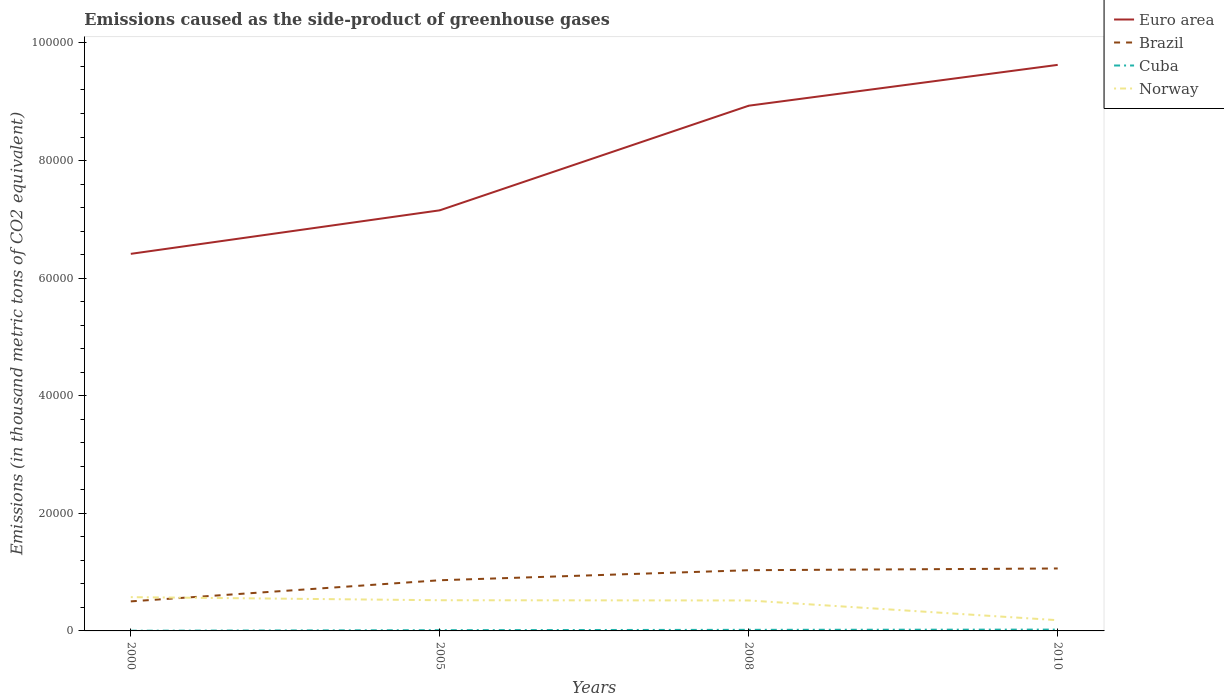Across all years, what is the maximum emissions caused as the side-product of greenhouse gases in Brazil?
Offer a terse response. 5025.2. What is the total emissions caused as the side-product of greenhouse gases in Brazil in the graph?
Offer a very short reply. -2003.5. What is the difference between the highest and the second highest emissions caused as the side-product of greenhouse gases in Norway?
Keep it short and to the point. 3919.8. What is the difference between the highest and the lowest emissions caused as the side-product of greenhouse gases in Euro area?
Keep it short and to the point. 2. How many years are there in the graph?
Your answer should be compact. 4. Are the values on the major ticks of Y-axis written in scientific E-notation?
Your response must be concise. No. Where does the legend appear in the graph?
Provide a short and direct response. Top right. What is the title of the graph?
Provide a short and direct response. Emissions caused as the side-product of greenhouse gases. What is the label or title of the X-axis?
Ensure brevity in your answer.  Years. What is the label or title of the Y-axis?
Give a very brief answer. Emissions (in thousand metric tons of CO2 equivalent). What is the Emissions (in thousand metric tons of CO2 equivalent) in Euro area in 2000?
Give a very brief answer. 6.41e+04. What is the Emissions (in thousand metric tons of CO2 equivalent) of Brazil in 2000?
Offer a terse response. 5025.2. What is the Emissions (in thousand metric tons of CO2 equivalent) of Cuba in 2000?
Your response must be concise. 34.2. What is the Emissions (in thousand metric tons of CO2 equivalent) in Norway in 2000?
Your answer should be very brief. 5742.8. What is the Emissions (in thousand metric tons of CO2 equivalent) in Euro area in 2005?
Keep it short and to the point. 7.15e+04. What is the Emissions (in thousand metric tons of CO2 equivalent) in Brazil in 2005?
Your response must be concise. 8617.5. What is the Emissions (in thousand metric tons of CO2 equivalent) in Cuba in 2005?
Offer a very short reply. 127.8. What is the Emissions (in thousand metric tons of CO2 equivalent) in Norway in 2005?
Your answer should be very brief. 5218.5. What is the Emissions (in thousand metric tons of CO2 equivalent) in Euro area in 2008?
Your answer should be compact. 8.93e+04. What is the Emissions (in thousand metric tons of CO2 equivalent) in Brazil in 2008?
Ensure brevity in your answer.  1.03e+04. What is the Emissions (in thousand metric tons of CO2 equivalent) of Cuba in 2008?
Provide a succinct answer. 185.9. What is the Emissions (in thousand metric tons of CO2 equivalent) in Norway in 2008?
Keep it short and to the point. 5179.9. What is the Emissions (in thousand metric tons of CO2 equivalent) of Euro area in 2010?
Ensure brevity in your answer.  9.63e+04. What is the Emissions (in thousand metric tons of CO2 equivalent) in Brazil in 2010?
Offer a very short reply. 1.06e+04. What is the Emissions (in thousand metric tons of CO2 equivalent) in Cuba in 2010?
Provide a succinct answer. 226. What is the Emissions (in thousand metric tons of CO2 equivalent) of Norway in 2010?
Keep it short and to the point. 1823. Across all years, what is the maximum Emissions (in thousand metric tons of CO2 equivalent) of Euro area?
Give a very brief answer. 9.63e+04. Across all years, what is the maximum Emissions (in thousand metric tons of CO2 equivalent) of Brazil?
Make the answer very short. 1.06e+04. Across all years, what is the maximum Emissions (in thousand metric tons of CO2 equivalent) of Cuba?
Make the answer very short. 226. Across all years, what is the maximum Emissions (in thousand metric tons of CO2 equivalent) in Norway?
Ensure brevity in your answer.  5742.8. Across all years, what is the minimum Emissions (in thousand metric tons of CO2 equivalent) of Euro area?
Ensure brevity in your answer.  6.41e+04. Across all years, what is the minimum Emissions (in thousand metric tons of CO2 equivalent) of Brazil?
Your answer should be very brief. 5025.2. Across all years, what is the minimum Emissions (in thousand metric tons of CO2 equivalent) in Cuba?
Give a very brief answer. 34.2. Across all years, what is the minimum Emissions (in thousand metric tons of CO2 equivalent) of Norway?
Offer a terse response. 1823. What is the total Emissions (in thousand metric tons of CO2 equivalent) of Euro area in the graph?
Offer a very short reply. 3.21e+05. What is the total Emissions (in thousand metric tons of CO2 equivalent) in Brazil in the graph?
Offer a very short reply. 3.46e+04. What is the total Emissions (in thousand metric tons of CO2 equivalent) in Cuba in the graph?
Make the answer very short. 573.9. What is the total Emissions (in thousand metric tons of CO2 equivalent) of Norway in the graph?
Make the answer very short. 1.80e+04. What is the difference between the Emissions (in thousand metric tons of CO2 equivalent) of Euro area in 2000 and that in 2005?
Make the answer very short. -7401.3. What is the difference between the Emissions (in thousand metric tons of CO2 equivalent) in Brazil in 2000 and that in 2005?
Offer a terse response. -3592.3. What is the difference between the Emissions (in thousand metric tons of CO2 equivalent) in Cuba in 2000 and that in 2005?
Provide a succinct answer. -93.6. What is the difference between the Emissions (in thousand metric tons of CO2 equivalent) in Norway in 2000 and that in 2005?
Your response must be concise. 524.3. What is the difference between the Emissions (in thousand metric tons of CO2 equivalent) in Euro area in 2000 and that in 2008?
Keep it short and to the point. -2.52e+04. What is the difference between the Emissions (in thousand metric tons of CO2 equivalent) in Brazil in 2000 and that in 2008?
Keep it short and to the point. -5301.4. What is the difference between the Emissions (in thousand metric tons of CO2 equivalent) of Cuba in 2000 and that in 2008?
Offer a terse response. -151.7. What is the difference between the Emissions (in thousand metric tons of CO2 equivalent) of Norway in 2000 and that in 2008?
Provide a short and direct response. 562.9. What is the difference between the Emissions (in thousand metric tons of CO2 equivalent) in Euro area in 2000 and that in 2010?
Ensure brevity in your answer.  -3.21e+04. What is the difference between the Emissions (in thousand metric tons of CO2 equivalent) in Brazil in 2000 and that in 2010?
Ensure brevity in your answer.  -5595.8. What is the difference between the Emissions (in thousand metric tons of CO2 equivalent) of Cuba in 2000 and that in 2010?
Keep it short and to the point. -191.8. What is the difference between the Emissions (in thousand metric tons of CO2 equivalent) of Norway in 2000 and that in 2010?
Offer a terse response. 3919.8. What is the difference between the Emissions (in thousand metric tons of CO2 equivalent) in Euro area in 2005 and that in 2008?
Your answer should be compact. -1.78e+04. What is the difference between the Emissions (in thousand metric tons of CO2 equivalent) in Brazil in 2005 and that in 2008?
Make the answer very short. -1709.1. What is the difference between the Emissions (in thousand metric tons of CO2 equivalent) in Cuba in 2005 and that in 2008?
Offer a terse response. -58.1. What is the difference between the Emissions (in thousand metric tons of CO2 equivalent) of Norway in 2005 and that in 2008?
Your answer should be very brief. 38.6. What is the difference between the Emissions (in thousand metric tons of CO2 equivalent) of Euro area in 2005 and that in 2010?
Make the answer very short. -2.47e+04. What is the difference between the Emissions (in thousand metric tons of CO2 equivalent) of Brazil in 2005 and that in 2010?
Your response must be concise. -2003.5. What is the difference between the Emissions (in thousand metric tons of CO2 equivalent) in Cuba in 2005 and that in 2010?
Give a very brief answer. -98.2. What is the difference between the Emissions (in thousand metric tons of CO2 equivalent) in Norway in 2005 and that in 2010?
Your answer should be compact. 3395.5. What is the difference between the Emissions (in thousand metric tons of CO2 equivalent) of Euro area in 2008 and that in 2010?
Ensure brevity in your answer.  -6944.7. What is the difference between the Emissions (in thousand metric tons of CO2 equivalent) in Brazil in 2008 and that in 2010?
Give a very brief answer. -294.4. What is the difference between the Emissions (in thousand metric tons of CO2 equivalent) in Cuba in 2008 and that in 2010?
Give a very brief answer. -40.1. What is the difference between the Emissions (in thousand metric tons of CO2 equivalent) of Norway in 2008 and that in 2010?
Your answer should be compact. 3356.9. What is the difference between the Emissions (in thousand metric tons of CO2 equivalent) in Euro area in 2000 and the Emissions (in thousand metric tons of CO2 equivalent) in Brazil in 2005?
Your response must be concise. 5.55e+04. What is the difference between the Emissions (in thousand metric tons of CO2 equivalent) of Euro area in 2000 and the Emissions (in thousand metric tons of CO2 equivalent) of Cuba in 2005?
Give a very brief answer. 6.40e+04. What is the difference between the Emissions (in thousand metric tons of CO2 equivalent) of Euro area in 2000 and the Emissions (in thousand metric tons of CO2 equivalent) of Norway in 2005?
Offer a very short reply. 5.89e+04. What is the difference between the Emissions (in thousand metric tons of CO2 equivalent) of Brazil in 2000 and the Emissions (in thousand metric tons of CO2 equivalent) of Cuba in 2005?
Ensure brevity in your answer.  4897.4. What is the difference between the Emissions (in thousand metric tons of CO2 equivalent) in Brazil in 2000 and the Emissions (in thousand metric tons of CO2 equivalent) in Norway in 2005?
Ensure brevity in your answer.  -193.3. What is the difference between the Emissions (in thousand metric tons of CO2 equivalent) of Cuba in 2000 and the Emissions (in thousand metric tons of CO2 equivalent) of Norway in 2005?
Make the answer very short. -5184.3. What is the difference between the Emissions (in thousand metric tons of CO2 equivalent) in Euro area in 2000 and the Emissions (in thousand metric tons of CO2 equivalent) in Brazil in 2008?
Provide a succinct answer. 5.38e+04. What is the difference between the Emissions (in thousand metric tons of CO2 equivalent) in Euro area in 2000 and the Emissions (in thousand metric tons of CO2 equivalent) in Cuba in 2008?
Make the answer very short. 6.39e+04. What is the difference between the Emissions (in thousand metric tons of CO2 equivalent) in Euro area in 2000 and the Emissions (in thousand metric tons of CO2 equivalent) in Norway in 2008?
Your answer should be compact. 5.89e+04. What is the difference between the Emissions (in thousand metric tons of CO2 equivalent) of Brazil in 2000 and the Emissions (in thousand metric tons of CO2 equivalent) of Cuba in 2008?
Your response must be concise. 4839.3. What is the difference between the Emissions (in thousand metric tons of CO2 equivalent) in Brazil in 2000 and the Emissions (in thousand metric tons of CO2 equivalent) in Norway in 2008?
Your answer should be very brief. -154.7. What is the difference between the Emissions (in thousand metric tons of CO2 equivalent) of Cuba in 2000 and the Emissions (in thousand metric tons of CO2 equivalent) of Norway in 2008?
Provide a short and direct response. -5145.7. What is the difference between the Emissions (in thousand metric tons of CO2 equivalent) of Euro area in 2000 and the Emissions (in thousand metric tons of CO2 equivalent) of Brazil in 2010?
Give a very brief answer. 5.35e+04. What is the difference between the Emissions (in thousand metric tons of CO2 equivalent) of Euro area in 2000 and the Emissions (in thousand metric tons of CO2 equivalent) of Cuba in 2010?
Your answer should be compact. 6.39e+04. What is the difference between the Emissions (in thousand metric tons of CO2 equivalent) of Euro area in 2000 and the Emissions (in thousand metric tons of CO2 equivalent) of Norway in 2010?
Your answer should be compact. 6.23e+04. What is the difference between the Emissions (in thousand metric tons of CO2 equivalent) in Brazil in 2000 and the Emissions (in thousand metric tons of CO2 equivalent) in Cuba in 2010?
Keep it short and to the point. 4799.2. What is the difference between the Emissions (in thousand metric tons of CO2 equivalent) of Brazil in 2000 and the Emissions (in thousand metric tons of CO2 equivalent) of Norway in 2010?
Make the answer very short. 3202.2. What is the difference between the Emissions (in thousand metric tons of CO2 equivalent) in Cuba in 2000 and the Emissions (in thousand metric tons of CO2 equivalent) in Norway in 2010?
Make the answer very short. -1788.8. What is the difference between the Emissions (in thousand metric tons of CO2 equivalent) of Euro area in 2005 and the Emissions (in thousand metric tons of CO2 equivalent) of Brazil in 2008?
Provide a short and direct response. 6.12e+04. What is the difference between the Emissions (in thousand metric tons of CO2 equivalent) in Euro area in 2005 and the Emissions (in thousand metric tons of CO2 equivalent) in Cuba in 2008?
Ensure brevity in your answer.  7.13e+04. What is the difference between the Emissions (in thousand metric tons of CO2 equivalent) of Euro area in 2005 and the Emissions (in thousand metric tons of CO2 equivalent) of Norway in 2008?
Your answer should be compact. 6.64e+04. What is the difference between the Emissions (in thousand metric tons of CO2 equivalent) in Brazil in 2005 and the Emissions (in thousand metric tons of CO2 equivalent) in Cuba in 2008?
Offer a terse response. 8431.6. What is the difference between the Emissions (in thousand metric tons of CO2 equivalent) of Brazil in 2005 and the Emissions (in thousand metric tons of CO2 equivalent) of Norway in 2008?
Provide a short and direct response. 3437.6. What is the difference between the Emissions (in thousand metric tons of CO2 equivalent) of Cuba in 2005 and the Emissions (in thousand metric tons of CO2 equivalent) of Norway in 2008?
Keep it short and to the point. -5052.1. What is the difference between the Emissions (in thousand metric tons of CO2 equivalent) in Euro area in 2005 and the Emissions (in thousand metric tons of CO2 equivalent) in Brazil in 2010?
Keep it short and to the point. 6.09e+04. What is the difference between the Emissions (in thousand metric tons of CO2 equivalent) of Euro area in 2005 and the Emissions (in thousand metric tons of CO2 equivalent) of Cuba in 2010?
Give a very brief answer. 7.13e+04. What is the difference between the Emissions (in thousand metric tons of CO2 equivalent) of Euro area in 2005 and the Emissions (in thousand metric tons of CO2 equivalent) of Norway in 2010?
Your response must be concise. 6.97e+04. What is the difference between the Emissions (in thousand metric tons of CO2 equivalent) of Brazil in 2005 and the Emissions (in thousand metric tons of CO2 equivalent) of Cuba in 2010?
Offer a very short reply. 8391.5. What is the difference between the Emissions (in thousand metric tons of CO2 equivalent) in Brazil in 2005 and the Emissions (in thousand metric tons of CO2 equivalent) in Norway in 2010?
Ensure brevity in your answer.  6794.5. What is the difference between the Emissions (in thousand metric tons of CO2 equivalent) in Cuba in 2005 and the Emissions (in thousand metric tons of CO2 equivalent) in Norway in 2010?
Offer a terse response. -1695.2. What is the difference between the Emissions (in thousand metric tons of CO2 equivalent) in Euro area in 2008 and the Emissions (in thousand metric tons of CO2 equivalent) in Brazil in 2010?
Offer a very short reply. 7.87e+04. What is the difference between the Emissions (in thousand metric tons of CO2 equivalent) in Euro area in 2008 and the Emissions (in thousand metric tons of CO2 equivalent) in Cuba in 2010?
Your answer should be very brief. 8.91e+04. What is the difference between the Emissions (in thousand metric tons of CO2 equivalent) of Euro area in 2008 and the Emissions (in thousand metric tons of CO2 equivalent) of Norway in 2010?
Give a very brief answer. 8.75e+04. What is the difference between the Emissions (in thousand metric tons of CO2 equivalent) in Brazil in 2008 and the Emissions (in thousand metric tons of CO2 equivalent) in Cuba in 2010?
Keep it short and to the point. 1.01e+04. What is the difference between the Emissions (in thousand metric tons of CO2 equivalent) in Brazil in 2008 and the Emissions (in thousand metric tons of CO2 equivalent) in Norway in 2010?
Offer a terse response. 8503.6. What is the difference between the Emissions (in thousand metric tons of CO2 equivalent) of Cuba in 2008 and the Emissions (in thousand metric tons of CO2 equivalent) of Norway in 2010?
Provide a succinct answer. -1637.1. What is the average Emissions (in thousand metric tons of CO2 equivalent) in Euro area per year?
Make the answer very short. 8.03e+04. What is the average Emissions (in thousand metric tons of CO2 equivalent) of Brazil per year?
Provide a succinct answer. 8647.58. What is the average Emissions (in thousand metric tons of CO2 equivalent) in Cuba per year?
Give a very brief answer. 143.47. What is the average Emissions (in thousand metric tons of CO2 equivalent) of Norway per year?
Ensure brevity in your answer.  4491.05. In the year 2000, what is the difference between the Emissions (in thousand metric tons of CO2 equivalent) of Euro area and Emissions (in thousand metric tons of CO2 equivalent) of Brazil?
Your response must be concise. 5.91e+04. In the year 2000, what is the difference between the Emissions (in thousand metric tons of CO2 equivalent) of Euro area and Emissions (in thousand metric tons of CO2 equivalent) of Cuba?
Give a very brief answer. 6.41e+04. In the year 2000, what is the difference between the Emissions (in thousand metric tons of CO2 equivalent) of Euro area and Emissions (in thousand metric tons of CO2 equivalent) of Norway?
Keep it short and to the point. 5.84e+04. In the year 2000, what is the difference between the Emissions (in thousand metric tons of CO2 equivalent) in Brazil and Emissions (in thousand metric tons of CO2 equivalent) in Cuba?
Give a very brief answer. 4991. In the year 2000, what is the difference between the Emissions (in thousand metric tons of CO2 equivalent) of Brazil and Emissions (in thousand metric tons of CO2 equivalent) of Norway?
Keep it short and to the point. -717.6. In the year 2000, what is the difference between the Emissions (in thousand metric tons of CO2 equivalent) of Cuba and Emissions (in thousand metric tons of CO2 equivalent) of Norway?
Offer a terse response. -5708.6. In the year 2005, what is the difference between the Emissions (in thousand metric tons of CO2 equivalent) in Euro area and Emissions (in thousand metric tons of CO2 equivalent) in Brazil?
Give a very brief answer. 6.29e+04. In the year 2005, what is the difference between the Emissions (in thousand metric tons of CO2 equivalent) of Euro area and Emissions (in thousand metric tons of CO2 equivalent) of Cuba?
Your answer should be very brief. 7.14e+04. In the year 2005, what is the difference between the Emissions (in thousand metric tons of CO2 equivalent) in Euro area and Emissions (in thousand metric tons of CO2 equivalent) in Norway?
Your answer should be very brief. 6.63e+04. In the year 2005, what is the difference between the Emissions (in thousand metric tons of CO2 equivalent) in Brazil and Emissions (in thousand metric tons of CO2 equivalent) in Cuba?
Your answer should be very brief. 8489.7. In the year 2005, what is the difference between the Emissions (in thousand metric tons of CO2 equivalent) of Brazil and Emissions (in thousand metric tons of CO2 equivalent) of Norway?
Your response must be concise. 3399. In the year 2005, what is the difference between the Emissions (in thousand metric tons of CO2 equivalent) of Cuba and Emissions (in thousand metric tons of CO2 equivalent) of Norway?
Offer a very short reply. -5090.7. In the year 2008, what is the difference between the Emissions (in thousand metric tons of CO2 equivalent) in Euro area and Emissions (in thousand metric tons of CO2 equivalent) in Brazil?
Provide a succinct answer. 7.90e+04. In the year 2008, what is the difference between the Emissions (in thousand metric tons of CO2 equivalent) of Euro area and Emissions (in thousand metric tons of CO2 equivalent) of Cuba?
Your answer should be compact. 8.91e+04. In the year 2008, what is the difference between the Emissions (in thousand metric tons of CO2 equivalent) of Euro area and Emissions (in thousand metric tons of CO2 equivalent) of Norway?
Your response must be concise. 8.41e+04. In the year 2008, what is the difference between the Emissions (in thousand metric tons of CO2 equivalent) of Brazil and Emissions (in thousand metric tons of CO2 equivalent) of Cuba?
Provide a short and direct response. 1.01e+04. In the year 2008, what is the difference between the Emissions (in thousand metric tons of CO2 equivalent) of Brazil and Emissions (in thousand metric tons of CO2 equivalent) of Norway?
Provide a succinct answer. 5146.7. In the year 2008, what is the difference between the Emissions (in thousand metric tons of CO2 equivalent) in Cuba and Emissions (in thousand metric tons of CO2 equivalent) in Norway?
Offer a terse response. -4994. In the year 2010, what is the difference between the Emissions (in thousand metric tons of CO2 equivalent) of Euro area and Emissions (in thousand metric tons of CO2 equivalent) of Brazil?
Make the answer very short. 8.56e+04. In the year 2010, what is the difference between the Emissions (in thousand metric tons of CO2 equivalent) of Euro area and Emissions (in thousand metric tons of CO2 equivalent) of Cuba?
Your answer should be very brief. 9.60e+04. In the year 2010, what is the difference between the Emissions (in thousand metric tons of CO2 equivalent) in Euro area and Emissions (in thousand metric tons of CO2 equivalent) in Norway?
Offer a very short reply. 9.44e+04. In the year 2010, what is the difference between the Emissions (in thousand metric tons of CO2 equivalent) in Brazil and Emissions (in thousand metric tons of CO2 equivalent) in Cuba?
Your response must be concise. 1.04e+04. In the year 2010, what is the difference between the Emissions (in thousand metric tons of CO2 equivalent) of Brazil and Emissions (in thousand metric tons of CO2 equivalent) of Norway?
Your response must be concise. 8798. In the year 2010, what is the difference between the Emissions (in thousand metric tons of CO2 equivalent) of Cuba and Emissions (in thousand metric tons of CO2 equivalent) of Norway?
Give a very brief answer. -1597. What is the ratio of the Emissions (in thousand metric tons of CO2 equivalent) in Euro area in 2000 to that in 2005?
Offer a terse response. 0.9. What is the ratio of the Emissions (in thousand metric tons of CO2 equivalent) of Brazil in 2000 to that in 2005?
Your answer should be compact. 0.58. What is the ratio of the Emissions (in thousand metric tons of CO2 equivalent) of Cuba in 2000 to that in 2005?
Provide a succinct answer. 0.27. What is the ratio of the Emissions (in thousand metric tons of CO2 equivalent) in Norway in 2000 to that in 2005?
Provide a short and direct response. 1.1. What is the ratio of the Emissions (in thousand metric tons of CO2 equivalent) in Euro area in 2000 to that in 2008?
Offer a terse response. 0.72. What is the ratio of the Emissions (in thousand metric tons of CO2 equivalent) in Brazil in 2000 to that in 2008?
Give a very brief answer. 0.49. What is the ratio of the Emissions (in thousand metric tons of CO2 equivalent) in Cuba in 2000 to that in 2008?
Offer a terse response. 0.18. What is the ratio of the Emissions (in thousand metric tons of CO2 equivalent) in Norway in 2000 to that in 2008?
Offer a terse response. 1.11. What is the ratio of the Emissions (in thousand metric tons of CO2 equivalent) in Euro area in 2000 to that in 2010?
Offer a terse response. 0.67. What is the ratio of the Emissions (in thousand metric tons of CO2 equivalent) in Brazil in 2000 to that in 2010?
Offer a terse response. 0.47. What is the ratio of the Emissions (in thousand metric tons of CO2 equivalent) of Cuba in 2000 to that in 2010?
Your answer should be very brief. 0.15. What is the ratio of the Emissions (in thousand metric tons of CO2 equivalent) of Norway in 2000 to that in 2010?
Provide a succinct answer. 3.15. What is the ratio of the Emissions (in thousand metric tons of CO2 equivalent) of Euro area in 2005 to that in 2008?
Ensure brevity in your answer.  0.8. What is the ratio of the Emissions (in thousand metric tons of CO2 equivalent) of Brazil in 2005 to that in 2008?
Your answer should be very brief. 0.83. What is the ratio of the Emissions (in thousand metric tons of CO2 equivalent) of Cuba in 2005 to that in 2008?
Your response must be concise. 0.69. What is the ratio of the Emissions (in thousand metric tons of CO2 equivalent) of Norway in 2005 to that in 2008?
Your answer should be compact. 1.01. What is the ratio of the Emissions (in thousand metric tons of CO2 equivalent) of Euro area in 2005 to that in 2010?
Provide a succinct answer. 0.74. What is the ratio of the Emissions (in thousand metric tons of CO2 equivalent) of Brazil in 2005 to that in 2010?
Your answer should be compact. 0.81. What is the ratio of the Emissions (in thousand metric tons of CO2 equivalent) in Cuba in 2005 to that in 2010?
Make the answer very short. 0.57. What is the ratio of the Emissions (in thousand metric tons of CO2 equivalent) in Norway in 2005 to that in 2010?
Offer a very short reply. 2.86. What is the ratio of the Emissions (in thousand metric tons of CO2 equivalent) in Euro area in 2008 to that in 2010?
Offer a very short reply. 0.93. What is the ratio of the Emissions (in thousand metric tons of CO2 equivalent) of Brazil in 2008 to that in 2010?
Your response must be concise. 0.97. What is the ratio of the Emissions (in thousand metric tons of CO2 equivalent) in Cuba in 2008 to that in 2010?
Give a very brief answer. 0.82. What is the ratio of the Emissions (in thousand metric tons of CO2 equivalent) of Norway in 2008 to that in 2010?
Your answer should be compact. 2.84. What is the difference between the highest and the second highest Emissions (in thousand metric tons of CO2 equivalent) in Euro area?
Give a very brief answer. 6944.7. What is the difference between the highest and the second highest Emissions (in thousand metric tons of CO2 equivalent) of Brazil?
Give a very brief answer. 294.4. What is the difference between the highest and the second highest Emissions (in thousand metric tons of CO2 equivalent) of Cuba?
Provide a short and direct response. 40.1. What is the difference between the highest and the second highest Emissions (in thousand metric tons of CO2 equivalent) of Norway?
Provide a succinct answer. 524.3. What is the difference between the highest and the lowest Emissions (in thousand metric tons of CO2 equivalent) in Euro area?
Ensure brevity in your answer.  3.21e+04. What is the difference between the highest and the lowest Emissions (in thousand metric tons of CO2 equivalent) of Brazil?
Provide a succinct answer. 5595.8. What is the difference between the highest and the lowest Emissions (in thousand metric tons of CO2 equivalent) in Cuba?
Ensure brevity in your answer.  191.8. What is the difference between the highest and the lowest Emissions (in thousand metric tons of CO2 equivalent) in Norway?
Ensure brevity in your answer.  3919.8. 